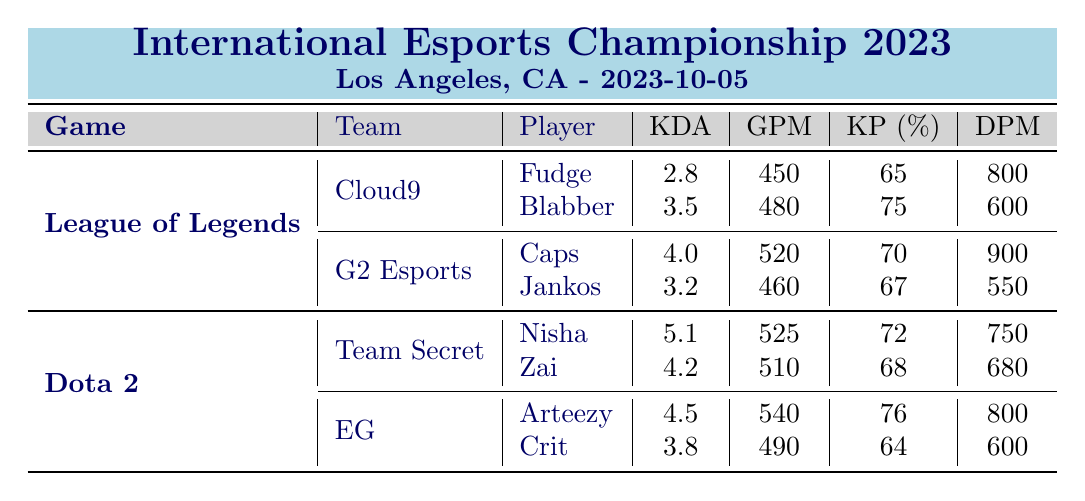What is the highest KDA in League of Legends? The highest KDA in League of Legends is found by comparing player performances. The players are Fudge (2.8), Blabber (3.5), Caps (4.0), and Jankos (3.2). The maximum among these is 4.0, which belongs to Caps.
Answer: 4.0 Which player had the lowest gold per minute in Dota 2? In Dota 2, the players' gold per minute values are Nisha (525), Zai (510), Arteezy (540), and Crit (490). The lowest value 490 corresponds to Crit.
Answer: Crit Is Jankos' kill participation percentage higher than that of Blabber? Jankos has a kill participation (KP) of 67%, while Blabber has a KP of 75%. Since 67% is less than 75%, Jankos' KP is not higher than Blabber's.
Answer: No What is the average KDA of the players in the Dota 2 teams? The KDA values for the Dota 2 players are Nisha (5.1), Zai (4.2), Arteezy (4.5), and Crit (3.8). To find the average, we sum them: 5.1 + 4.2 + 4.5 + 3.8 = 17.6. There are 4 players, thus the average is 17.6 / 4 = 4.4.
Answer: 4.4 Which team had the best overall damage per minute in League of Legends? To determine the team with the best overall damage per minute, we sum the damage per minute (DPM) for each team's players: Cloud9 (Fudge 800 + Blabber 600 = 1400 DPM) and G2 Esports (Caps 900 + Jankos 550 = 1450 DPM). G2 Esports has a total of 1450, which is greater than Cloud9's 1400. Thus, G2 Esports had the best DPM.
Answer: G2 Esports 